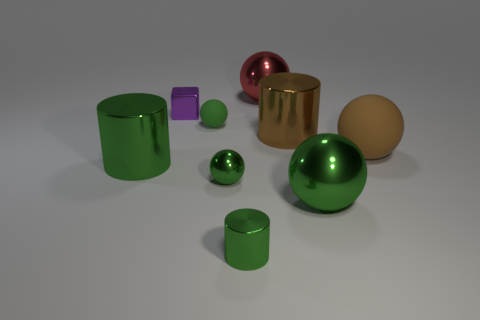Subtract all big green shiny cylinders. How many cylinders are left? 2 Subtract all yellow cylinders. How many green spheres are left? 3 Subtract all red spheres. How many spheres are left? 4 Add 1 big red matte balls. How many objects exist? 10 Subtract all red spheres. Subtract all gray cubes. How many spheres are left? 4 Subtract all cyan metallic cubes. Subtract all small green shiny things. How many objects are left? 7 Add 6 large brown things. How many large brown things are left? 8 Add 6 small yellow balls. How many small yellow balls exist? 6 Subtract 0 blue balls. How many objects are left? 9 Subtract all cylinders. How many objects are left? 6 